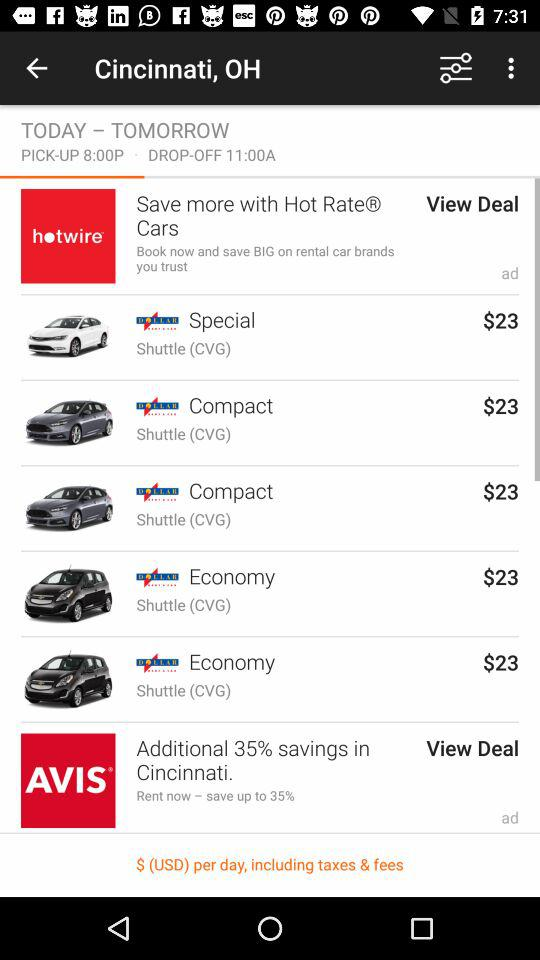What is the drop-off time? The drop-off time is 11:00 am. 